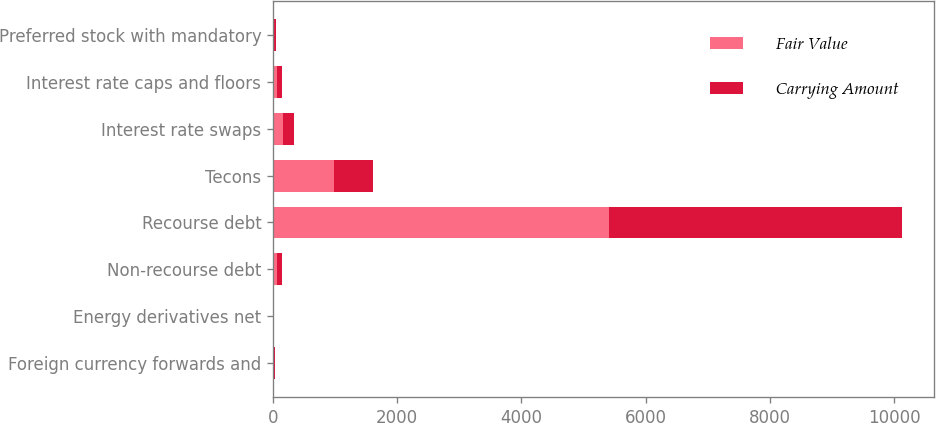<chart> <loc_0><loc_0><loc_500><loc_500><stacked_bar_chart><ecel><fcel>Foreign currency forwards and<fcel>Energy derivatives net<fcel>Non-recourse debt<fcel>Recourse debt<fcel>Tecons<fcel>Interest rate swaps<fcel>Interest rate caps and floors<fcel>Preferred stock with mandatory<nl><fcel>Fair Value<fcel>14<fcel>7<fcel>72<fcel>5401<fcel>978<fcel>166<fcel>72<fcel>22<nl><fcel>Carrying Amount<fcel>14<fcel>7<fcel>72<fcel>4730<fcel>626<fcel>166<fcel>72<fcel>22<nl></chart> 